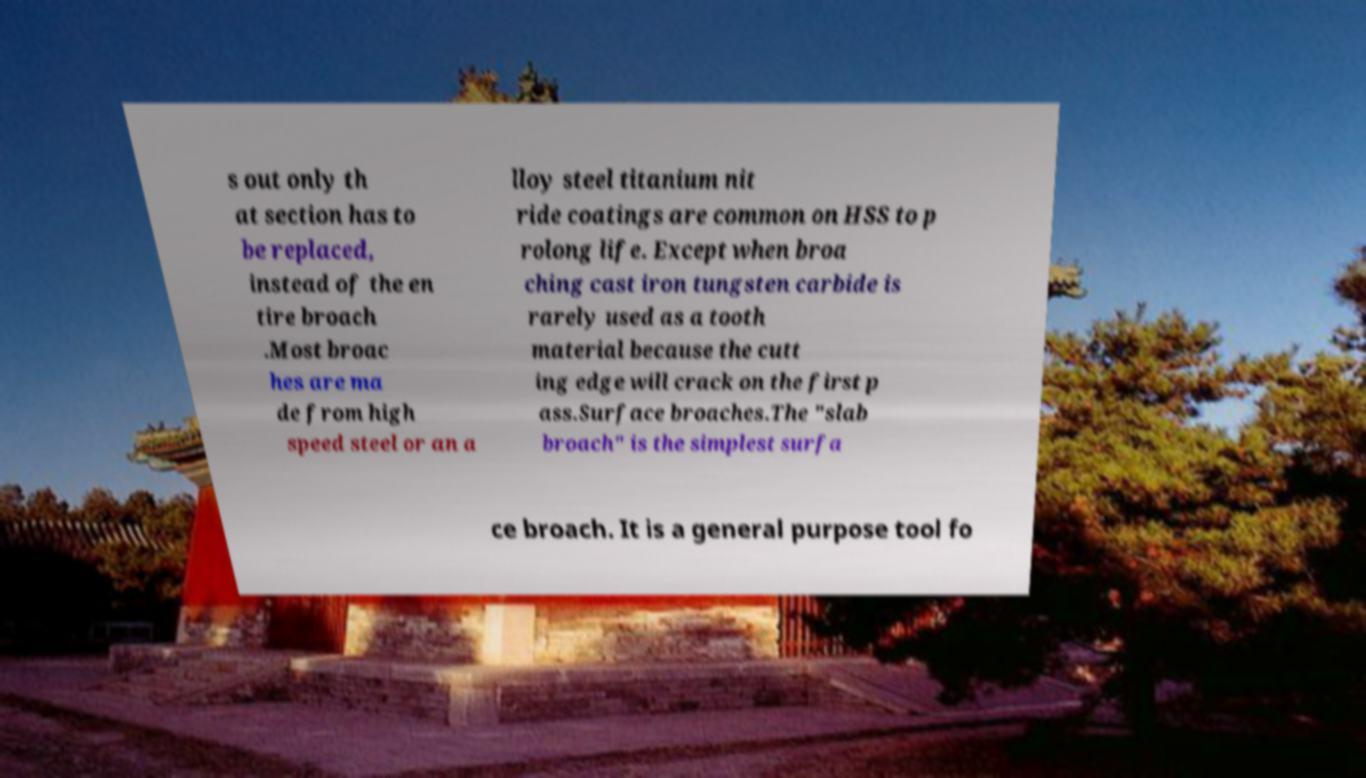What messages or text are displayed in this image? I need them in a readable, typed format. s out only th at section has to be replaced, instead of the en tire broach .Most broac hes are ma de from high speed steel or an a lloy steel titanium nit ride coatings are common on HSS to p rolong life. Except when broa ching cast iron tungsten carbide is rarely used as a tooth material because the cutt ing edge will crack on the first p ass.Surface broaches.The "slab broach" is the simplest surfa ce broach. It is a general purpose tool fo 